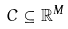Convert formula to latex. <formula><loc_0><loc_0><loc_500><loc_500>C \subseteq \mathbb { R } ^ { M }</formula> 